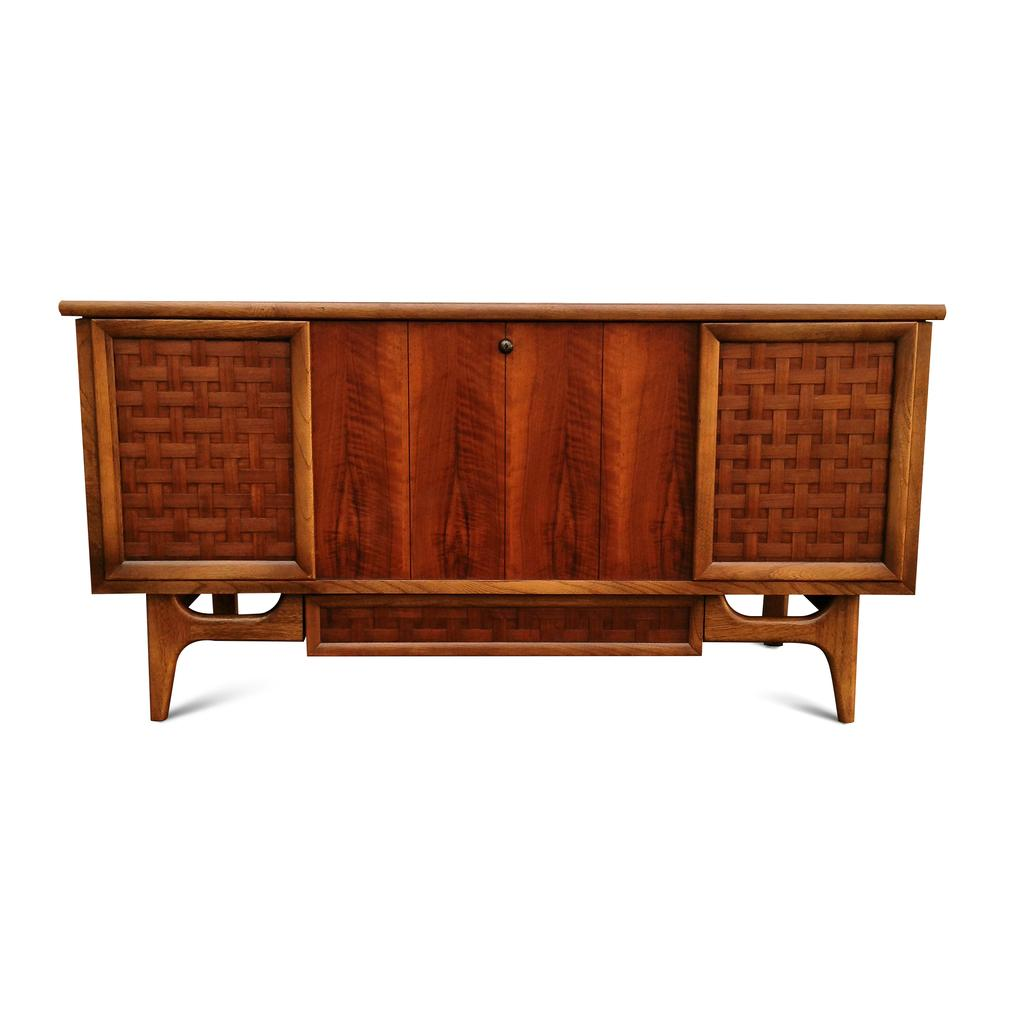What is located in the center of the image? There is a table in the center of the image. What type of bag is hanging from the heart in the image? There is no bag or heart present in the image; it only features a table in the center. 